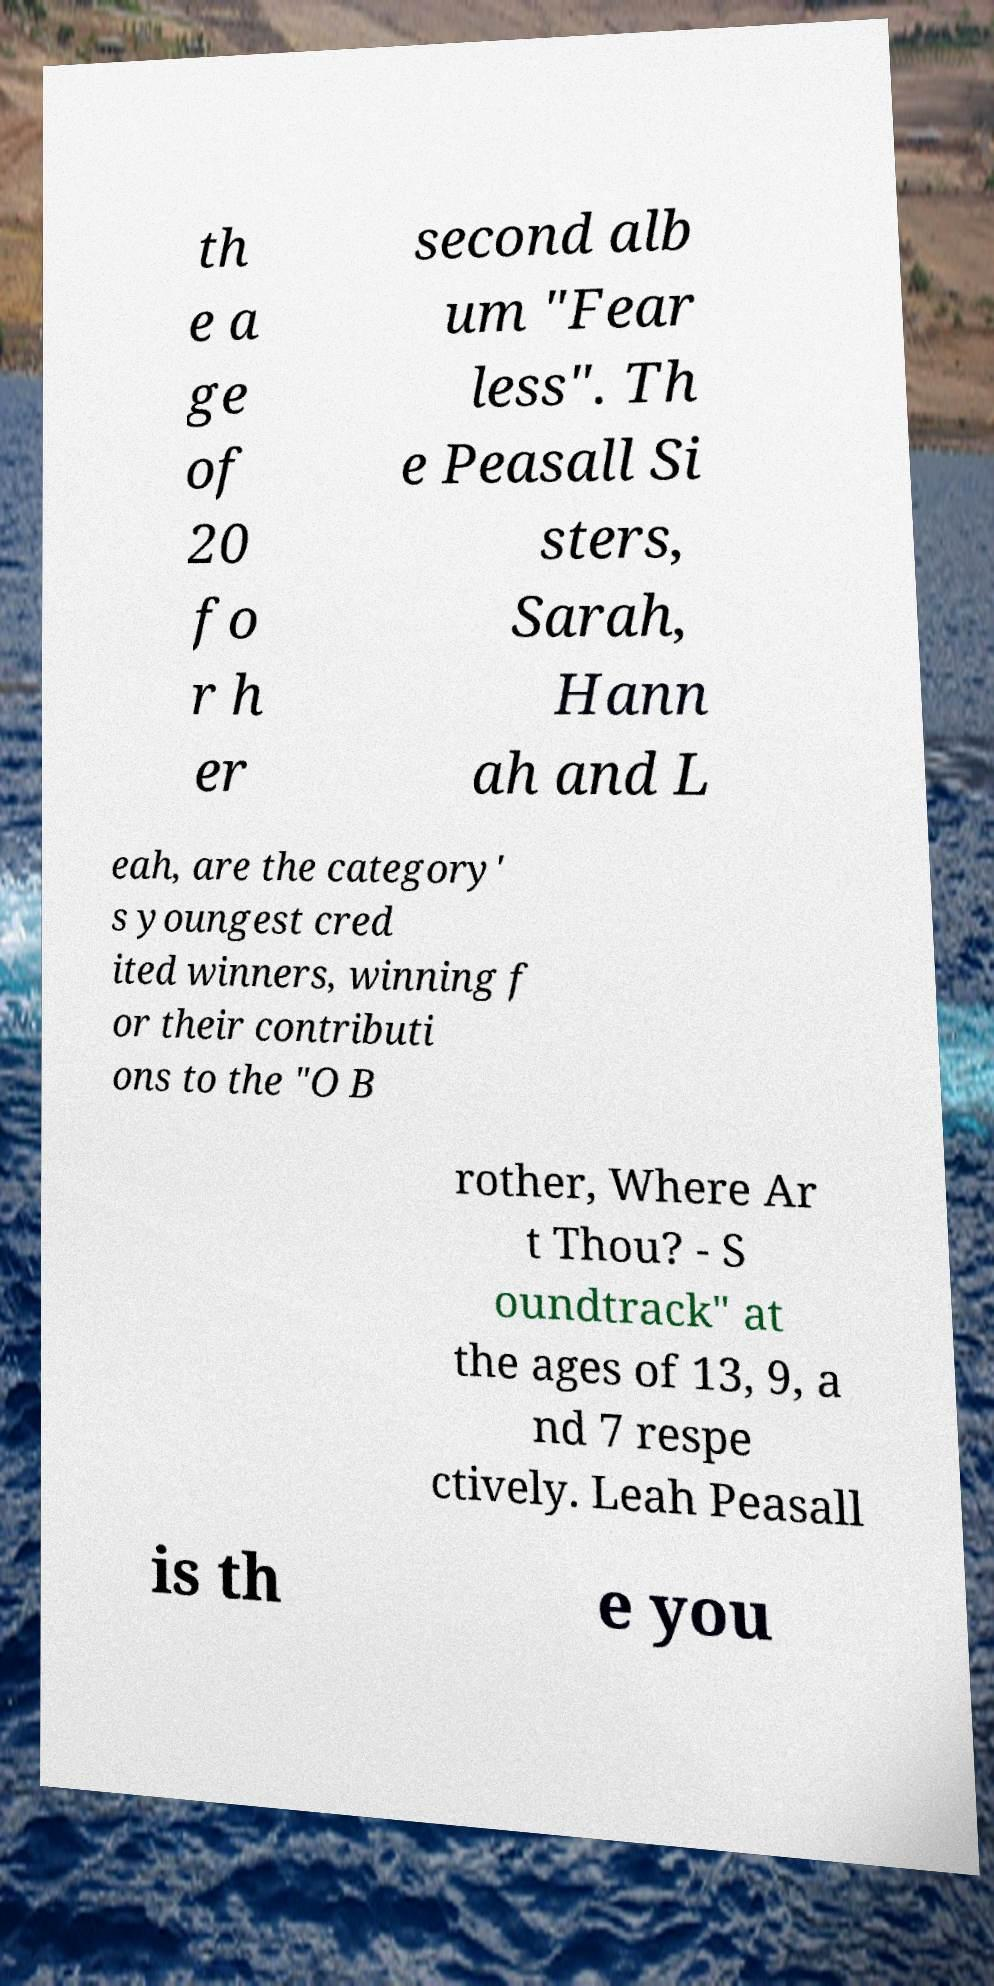I need the written content from this picture converted into text. Can you do that? th e a ge of 20 fo r h er second alb um "Fear less". Th e Peasall Si sters, Sarah, Hann ah and L eah, are the category' s youngest cred ited winners, winning f or their contributi ons to the "O B rother, Where Ar t Thou? - S oundtrack" at the ages of 13, 9, a nd 7 respe ctively. Leah Peasall is th e you 